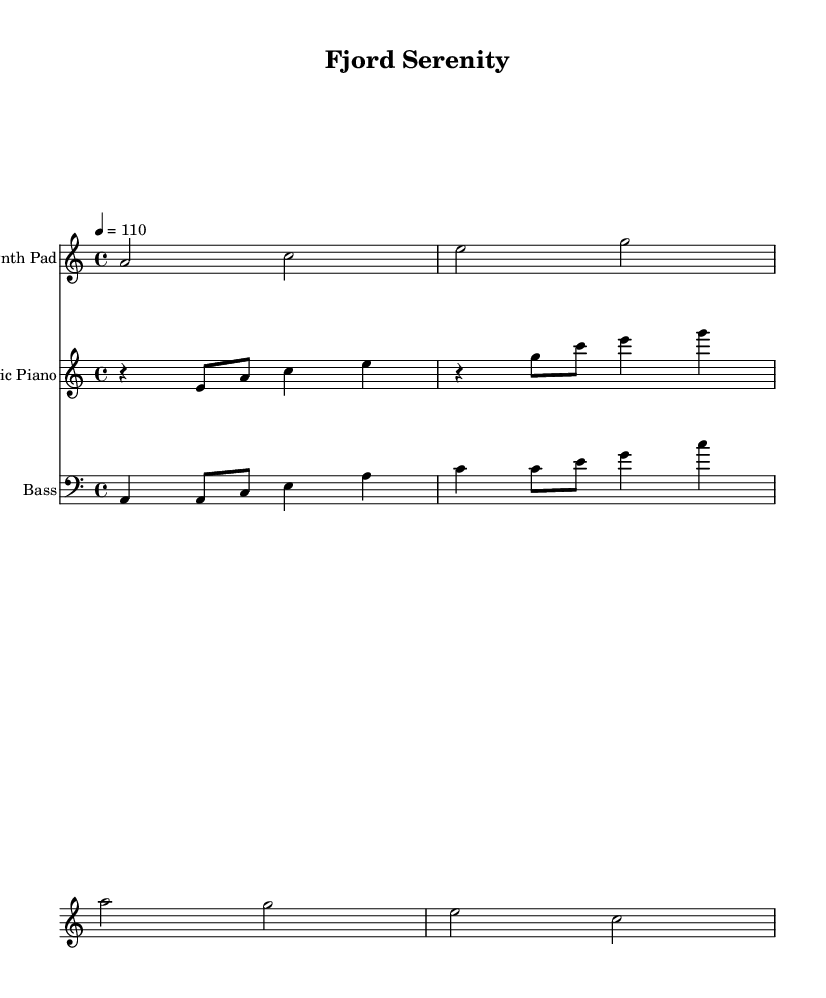What is the key signature of this music? The key signature indicates that the piece is in A minor, which has no sharps or flats. This is confirmed by looking at the key signature indicator, which is shown at the beginning of the staff for each instrument.
Answer: A minor What is the time signature of this music? The time signature is depicted at the beginning of the score and indicates that the piece is in 4/4 time, meaning there are four beats in each measure. This is essential for the rhythm and is typically represented by the "4/4" notation.
Answer: 4/4 What is the tempo marking of this music? The tempo is indicated at the beginning of the score with the marking "4 = 110", specifying that there are 110 beats per minute. This lays out the speed at which the piece should be played, allowing musicians to maintain a consistent pace.
Answer: 110 How many measures are shown in the Synth Pad part? By counting the measures in the Synth Pad staff, we can see that there are four measures present, with each distinct grouping separated by vertical bar lines. This provides a clear structure to the music, allowing musicians to follow along easily.
Answer: 4 Which instrument plays the lowest notes? The instrument labeled "Bass" plays the lowest notes in the score, as indicated by the clef placement and the range of notes used. The bass clef signifies that this instrument typically plays lower pitches compared to the other instruments presented.
Answer: Bass What is the rhythmic pattern of the Electric Piano for the first measure? The first measure for the Electric Piano consists of a rest followed by two eighth notes and then two quarter notes, creating a rhythm that emphasizes the second and fourth beats in a typical house music style. This can be deduced by analyzing the note durations laid out in the first measure.
Answer: Rest, eighth, eighth, quarter, quarter What is the relationship between the Synth Pad and Electric Piano in this piece? The Synth Pad provides a harmonic background or texture while the Electric Piano contributes melodic elements. This interplay is characteristic of chill-out house music, where atmospheric sounds support the main thematic material, showcasing a blend of texture and melody.
Answer: Harmonic and melodic interplay 